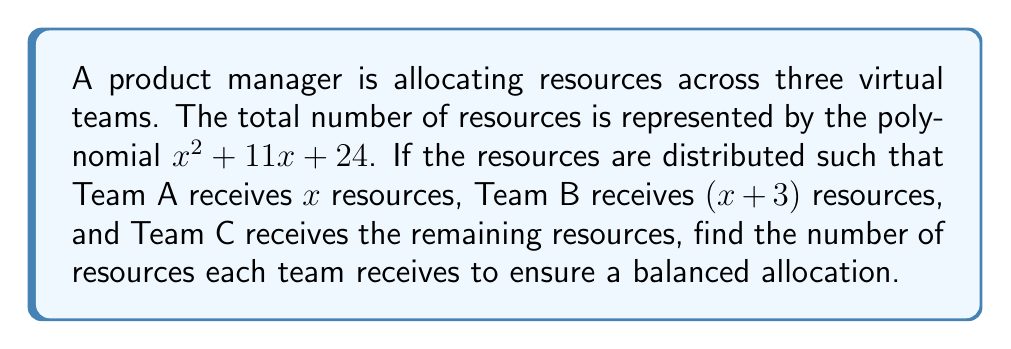Can you answer this question? 1) First, we need to factor the polynomial $x^2 + 11x + 24$ to find the total number of resources:

   $x^2 + 11x + 24 = (x + 8)(x + 3)$

2) Now, we know that:
   - Team A receives $x$ resources
   - Team B receives $(x+3)$ resources
   - Team C receives the remaining resources

3) To find Team C's resources, we subtract Team A and Team B's resources from the total:

   Team C = $(x + 8)(x + 3) - x - (x+3)$
          = $x^2 + 11x + 24 - x - x - 3$
          = $x^2 + 9x + 21$

4) For a balanced allocation, all teams should receive the same number of resources. So:

   $x = x + 3 = x^2 + 9x + 21$

5) Solving the equation $x = x^2 + 9x + 21$:

   $0 = x^2 + 8x + 21$
   $0 = (x + 7)(x + 3)$

6) The solution $x = -3$ is not practical for resource allocation. Therefore, $x = -7$.

7) Substituting $x = -7$ into the original expressions:
   - Team A: $-7$ (which is 7 resources)
   - Team B: $-7 + 3 = -4$ (which is 4 resources)
   - Team C: $(-7)^2 + 9(-7) + 21 = 49 - 63 + 21 = 7$ resources
Answer: Team A: 7, Team B: 7, Team C: 7 